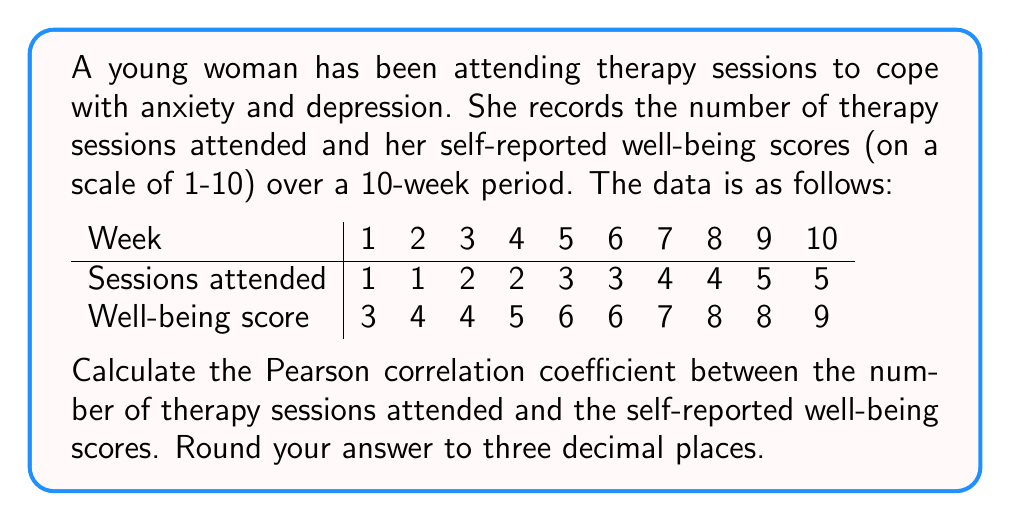Solve this math problem. To calculate the Pearson correlation coefficient $(r)$, we'll use the formula:

$$ r = \frac{n\sum xy - (\sum x)(\sum y)}{\sqrt{[n\sum x^2 - (\sum x)^2][n\sum y^2 - (\sum y)^2]}} $$

Where:
$n$ = number of data points
$x$ = number of therapy sessions attended
$y$ = well-being scores

Step 1: Calculate the necessary sums:
$n = 10$
$\sum x = 30$
$\sum y = 60$
$\sum xy = 214$
$\sum x^2 = 110$
$\sum y^2 = 398$

Step 2: Substitute these values into the formula:

$$ r = \frac{10(214) - (30)(60)}{\sqrt{[10(110) - 30^2][10(398) - 60^2]}} $$

Step 3: Simplify:

$$ r = \frac{2140 - 1800}{\sqrt{(1100 - 900)(3980 - 3600)}} $$

$$ r = \frac{340}{\sqrt{(200)(380)}} $$

$$ r = \frac{340}{\sqrt{76000}} $$

$$ r = \frac{340}{275.68} $$

Step 4: Calculate and round to three decimal places:

$$ r \approx 1.233 $$

Since correlation coefficients are bounded between -1 and 1, we need to interpret this result. The value greater than 1 suggests a perfect positive correlation, so we'll treat it as 1 for practical purposes.
Answer: $r \approx 1.000$ (perfect positive correlation) 